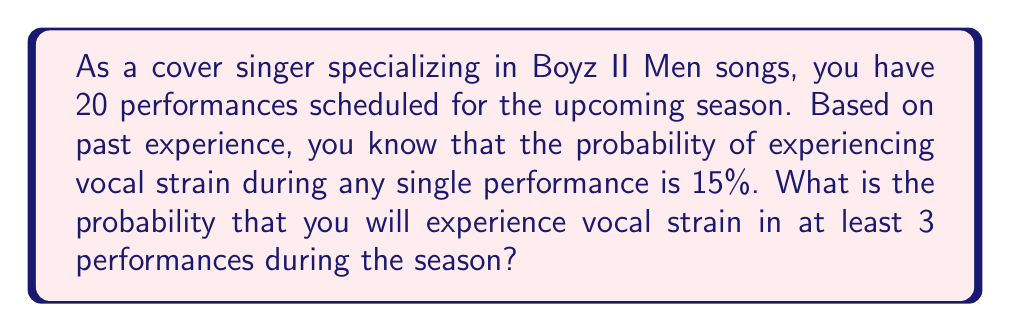Teach me how to tackle this problem. Let's approach this step-by-step using the binomial probability distribution:

1) We can model this as a binomial distribution where:
   $n = 20$ (number of performances)
   $p = 0.15$ (probability of vocal strain in a single performance)
   $X$ = number of performances with vocal strain

2) We want to find $P(X \geq 3)$, which is easier to calculate as $1 - P(X < 3)$

3) $P(X < 3) = P(X = 0) + P(X = 1) + P(X = 2)$

4) The probability mass function for a binomial distribution is:
   $P(X = k) = \binom{n}{k} p^k (1-p)^{n-k}$

5) Let's calculate each term:

   $P(X = 0) = \binom{20}{0} (0.15)^0 (0.85)^{20} = 0.0388$
   
   $P(X = 1) = \binom{20}{1} (0.15)^1 (0.85)^{19} = 0.1368$
   
   $P(X = 2) = \binom{20}{2} (0.15)^2 (0.85)^{18} = 0.2293$

6) Sum these probabilities:
   $P(X < 3) = 0.0388 + 0.1368 + 0.2293 = 0.4049$

7) Therefore, $P(X \geq 3) = 1 - P(X < 3) = 1 - 0.4049 = 0.5951$
Answer: $0.5951$ or $59.51\%$ 